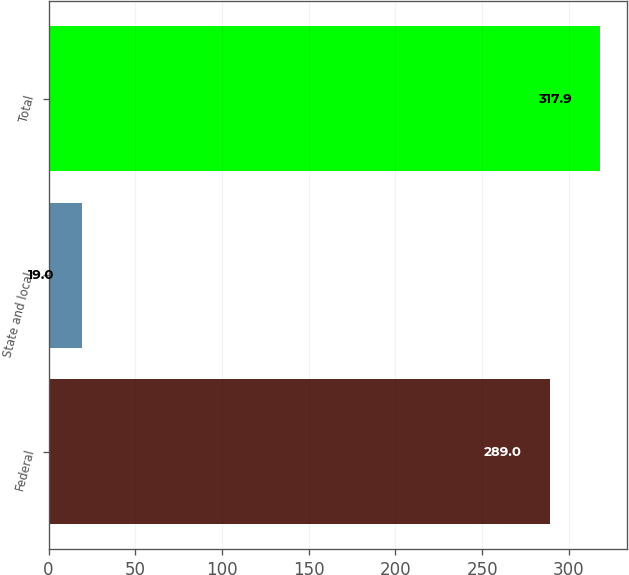Convert chart to OTSL. <chart><loc_0><loc_0><loc_500><loc_500><bar_chart><fcel>Federal<fcel>State and local<fcel>Total<nl><fcel>289<fcel>19<fcel>317.9<nl></chart> 